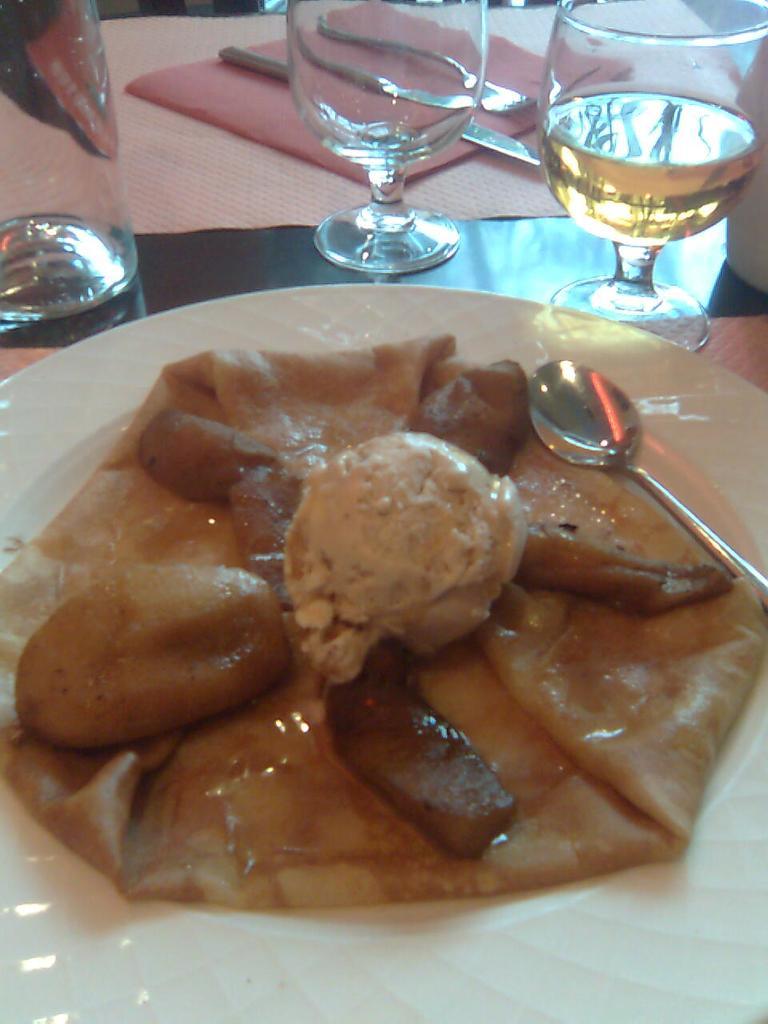In one or two sentences, can you explain what this image depicts? In this image we can see a food item and spoon in a white color plate. At the top of the image, we can see glasses, knife, fork, cloth and napkin. 